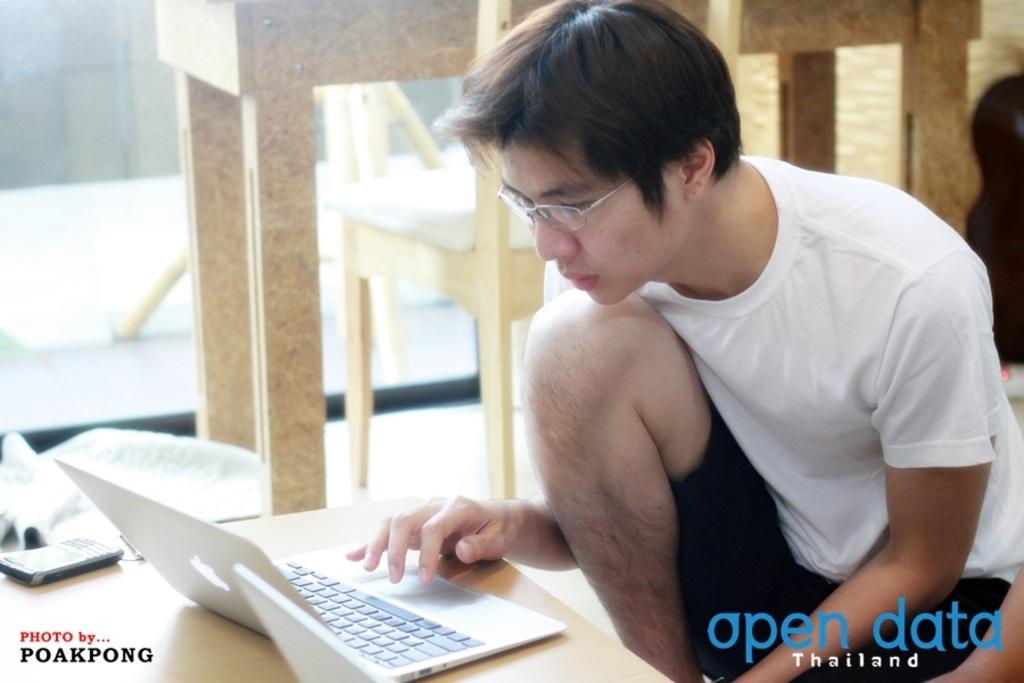What is the person in the image doing? The person is sitting at the table in the image. What electronic devices are on the table? There is a mobile phone and a laptop on the table. What can be seen in the background of the image? There are chairs and another table in the background of the image. What type of boats can be seen in the image? There are no boats present in the image. What part of the person's neck is visible in the image? The image does not show any part of the person's neck. 